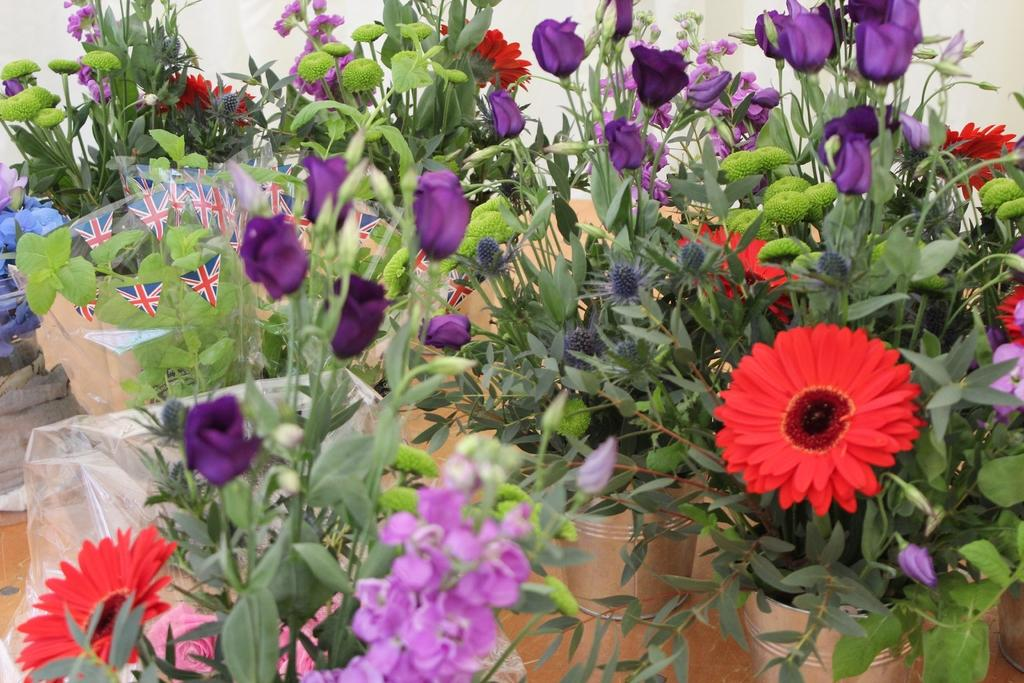What type of plants can be seen on the floor in the image? There are pot plants on the floor in the image. What can be observed about the flowers on the pot plants? The flowers on the pot plants have different colors. What is visible in the background of the image? There is a white wall in the background. What type of popcorn is being prepared by the carpenter in the image? There is no popcorn or carpenter present in the image. 